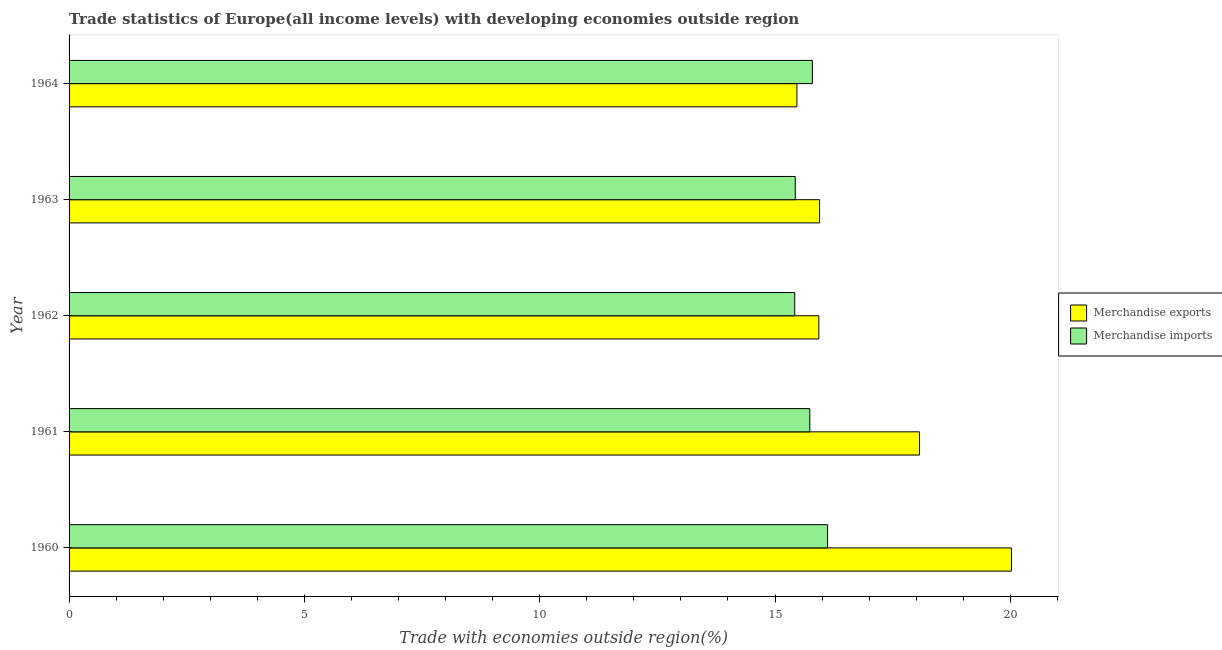How many different coloured bars are there?
Your response must be concise. 2. Are the number of bars on each tick of the Y-axis equal?
Keep it short and to the point. Yes. What is the label of the 4th group of bars from the top?
Offer a very short reply. 1961. In how many cases, is the number of bars for a given year not equal to the number of legend labels?
Give a very brief answer. 0. What is the merchandise exports in 1961?
Make the answer very short. 18.07. Across all years, what is the maximum merchandise exports?
Make the answer very short. 20.02. Across all years, what is the minimum merchandise exports?
Provide a short and direct response. 15.47. In which year was the merchandise imports maximum?
Your answer should be compact. 1960. What is the total merchandise imports in the graph?
Provide a succinct answer. 78.5. What is the difference between the merchandise exports in 1960 and that in 1963?
Provide a succinct answer. 4.08. What is the difference between the merchandise imports in 1962 and the merchandise exports in 1963?
Keep it short and to the point. -0.53. What is the average merchandise imports per year?
Your answer should be very brief. 15.7. In the year 1962, what is the difference between the merchandise exports and merchandise imports?
Your answer should be compact. 0.51. In how many years, is the merchandise exports greater than 20 %?
Make the answer very short. 1. What is the ratio of the merchandise exports in 1960 to that in 1964?
Keep it short and to the point. 1.29. Is the difference between the merchandise imports in 1962 and 1963 greater than the difference between the merchandise exports in 1962 and 1963?
Your response must be concise. Yes. What is the difference between the highest and the second highest merchandise exports?
Provide a short and direct response. 1.95. What is the difference between the highest and the lowest merchandise exports?
Your answer should be compact. 4.56. How many legend labels are there?
Provide a short and direct response. 2. What is the title of the graph?
Offer a very short reply. Trade statistics of Europe(all income levels) with developing economies outside region. What is the label or title of the X-axis?
Provide a succinct answer. Trade with economies outside region(%). What is the Trade with economies outside region(%) of Merchandise exports in 1960?
Give a very brief answer. 20.02. What is the Trade with economies outside region(%) of Merchandise imports in 1960?
Keep it short and to the point. 16.12. What is the Trade with economies outside region(%) of Merchandise exports in 1961?
Your response must be concise. 18.07. What is the Trade with economies outside region(%) in Merchandise imports in 1961?
Give a very brief answer. 15.74. What is the Trade with economies outside region(%) of Merchandise exports in 1962?
Keep it short and to the point. 15.93. What is the Trade with economies outside region(%) in Merchandise imports in 1962?
Ensure brevity in your answer.  15.42. What is the Trade with economies outside region(%) of Merchandise exports in 1963?
Your answer should be compact. 15.95. What is the Trade with economies outside region(%) of Merchandise imports in 1963?
Make the answer very short. 15.43. What is the Trade with economies outside region(%) in Merchandise exports in 1964?
Your answer should be very brief. 15.47. What is the Trade with economies outside region(%) in Merchandise imports in 1964?
Your response must be concise. 15.79. Across all years, what is the maximum Trade with economies outside region(%) in Merchandise exports?
Your answer should be compact. 20.02. Across all years, what is the maximum Trade with economies outside region(%) in Merchandise imports?
Give a very brief answer. 16.12. Across all years, what is the minimum Trade with economies outside region(%) of Merchandise exports?
Make the answer very short. 15.47. Across all years, what is the minimum Trade with economies outside region(%) of Merchandise imports?
Offer a terse response. 15.42. What is the total Trade with economies outside region(%) in Merchandise exports in the graph?
Offer a terse response. 85.44. What is the total Trade with economies outside region(%) of Merchandise imports in the graph?
Your answer should be very brief. 78.5. What is the difference between the Trade with economies outside region(%) in Merchandise exports in 1960 and that in 1961?
Your answer should be very brief. 1.95. What is the difference between the Trade with economies outside region(%) of Merchandise imports in 1960 and that in 1961?
Your answer should be very brief. 0.38. What is the difference between the Trade with economies outside region(%) of Merchandise exports in 1960 and that in 1962?
Offer a very short reply. 4.09. What is the difference between the Trade with economies outside region(%) of Merchandise imports in 1960 and that in 1962?
Provide a short and direct response. 0.7. What is the difference between the Trade with economies outside region(%) in Merchandise exports in 1960 and that in 1963?
Offer a very short reply. 4.08. What is the difference between the Trade with economies outside region(%) in Merchandise imports in 1960 and that in 1963?
Keep it short and to the point. 0.69. What is the difference between the Trade with economies outside region(%) in Merchandise exports in 1960 and that in 1964?
Your answer should be very brief. 4.56. What is the difference between the Trade with economies outside region(%) of Merchandise imports in 1960 and that in 1964?
Your answer should be compact. 0.32. What is the difference between the Trade with economies outside region(%) in Merchandise exports in 1961 and that in 1962?
Keep it short and to the point. 2.14. What is the difference between the Trade with economies outside region(%) in Merchandise imports in 1961 and that in 1962?
Offer a terse response. 0.32. What is the difference between the Trade with economies outside region(%) in Merchandise exports in 1961 and that in 1963?
Your answer should be very brief. 2.12. What is the difference between the Trade with economies outside region(%) of Merchandise imports in 1961 and that in 1963?
Your answer should be compact. 0.31. What is the difference between the Trade with economies outside region(%) in Merchandise exports in 1961 and that in 1964?
Give a very brief answer. 2.61. What is the difference between the Trade with economies outside region(%) of Merchandise imports in 1961 and that in 1964?
Offer a very short reply. -0.06. What is the difference between the Trade with economies outside region(%) in Merchandise exports in 1962 and that in 1963?
Provide a succinct answer. -0.02. What is the difference between the Trade with economies outside region(%) of Merchandise imports in 1962 and that in 1963?
Give a very brief answer. -0.01. What is the difference between the Trade with economies outside region(%) of Merchandise exports in 1962 and that in 1964?
Provide a short and direct response. 0.47. What is the difference between the Trade with economies outside region(%) in Merchandise imports in 1962 and that in 1964?
Keep it short and to the point. -0.38. What is the difference between the Trade with economies outside region(%) of Merchandise exports in 1963 and that in 1964?
Offer a very short reply. 0.48. What is the difference between the Trade with economies outside region(%) in Merchandise imports in 1963 and that in 1964?
Give a very brief answer. -0.36. What is the difference between the Trade with economies outside region(%) of Merchandise exports in 1960 and the Trade with economies outside region(%) of Merchandise imports in 1961?
Provide a succinct answer. 4.29. What is the difference between the Trade with economies outside region(%) of Merchandise exports in 1960 and the Trade with economies outside region(%) of Merchandise imports in 1962?
Your answer should be very brief. 4.61. What is the difference between the Trade with economies outside region(%) in Merchandise exports in 1960 and the Trade with economies outside region(%) in Merchandise imports in 1963?
Your answer should be very brief. 4.59. What is the difference between the Trade with economies outside region(%) of Merchandise exports in 1960 and the Trade with economies outside region(%) of Merchandise imports in 1964?
Provide a succinct answer. 4.23. What is the difference between the Trade with economies outside region(%) of Merchandise exports in 1961 and the Trade with economies outside region(%) of Merchandise imports in 1962?
Provide a succinct answer. 2.65. What is the difference between the Trade with economies outside region(%) in Merchandise exports in 1961 and the Trade with economies outside region(%) in Merchandise imports in 1963?
Make the answer very short. 2.64. What is the difference between the Trade with economies outside region(%) in Merchandise exports in 1961 and the Trade with economies outside region(%) in Merchandise imports in 1964?
Make the answer very short. 2.28. What is the difference between the Trade with economies outside region(%) in Merchandise exports in 1962 and the Trade with economies outside region(%) in Merchandise imports in 1963?
Offer a very short reply. 0.5. What is the difference between the Trade with economies outside region(%) of Merchandise exports in 1962 and the Trade with economies outside region(%) of Merchandise imports in 1964?
Make the answer very short. 0.14. What is the difference between the Trade with economies outside region(%) of Merchandise exports in 1963 and the Trade with economies outside region(%) of Merchandise imports in 1964?
Your answer should be very brief. 0.15. What is the average Trade with economies outside region(%) in Merchandise exports per year?
Give a very brief answer. 17.09. What is the average Trade with economies outside region(%) in Merchandise imports per year?
Offer a very short reply. 15.7. In the year 1960, what is the difference between the Trade with economies outside region(%) in Merchandise exports and Trade with economies outside region(%) in Merchandise imports?
Provide a short and direct response. 3.91. In the year 1961, what is the difference between the Trade with economies outside region(%) in Merchandise exports and Trade with economies outside region(%) in Merchandise imports?
Offer a terse response. 2.33. In the year 1962, what is the difference between the Trade with economies outside region(%) in Merchandise exports and Trade with economies outside region(%) in Merchandise imports?
Your answer should be compact. 0.51. In the year 1963, what is the difference between the Trade with economies outside region(%) of Merchandise exports and Trade with economies outside region(%) of Merchandise imports?
Give a very brief answer. 0.52. In the year 1964, what is the difference between the Trade with economies outside region(%) of Merchandise exports and Trade with economies outside region(%) of Merchandise imports?
Your response must be concise. -0.33. What is the ratio of the Trade with economies outside region(%) in Merchandise exports in 1960 to that in 1961?
Ensure brevity in your answer.  1.11. What is the ratio of the Trade with economies outside region(%) in Merchandise imports in 1960 to that in 1961?
Your answer should be compact. 1.02. What is the ratio of the Trade with economies outside region(%) of Merchandise exports in 1960 to that in 1962?
Provide a succinct answer. 1.26. What is the ratio of the Trade with economies outside region(%) in Merchandise imports in 1960 to that in 1962?
Offer a very short reply. 1.05. What is the ratio of the Trade with economies outside region(%) of Merchandise exports in 1960 to that in 1963?
Make the answer very short. 1.26. What is the ratio of the Trade with economies outside region(%) in Merchandise imports in 1960 to that in 1963?
Your answer should be compact. 1.04. What is the ratio of the Trade with economies outside region(%) of Merchandise exports in 1960 to that in 1964?
Ensure brevity in your answer.  1.29. What is the ratio of the Trade with economies outside region(%) of Merchandise imports in 1960 to that in 1964?
Give a very brief answer. 1.02. What is the ratio of the Trade with economies outside region(%) of Merchandise exports in 1961 to that in 1962?
Make the answer very short. 1.13. What is the ratio of the Trade with economies outside region(%) of Merchandise imports in 1961 to that in 1962?
Your answer should be compact. 1.02. What is the ratio of the Trade with economies outside region(%) in Merchandise exports in 1961 to that in 1963?
Ensure brevity in your answer.  1.13. What is the ratio of the Trade with economies outside region(%) of Merchandise imports in 1961 to that in 1963?
Make the answer very short. 1.02. What is the ratio of the Trade with economies outside region(%) in Merchandise exports in 1961 to that in 1964?
Provide a short and direct response. 1.17. What is the ratio of the Trade with economies outside region(%) in Merchandise imports in 1961 to that in 1964?
Your response must be concise. 1. What is the ratio of the Trade with economies outside region(%) of Merchandise exports in 1962 to that in 1963?
Ensure brevity in your answer.  1. What is the ratio of the Trade with economies outside region(%) in Merchandise imports in 1962 to that in 1963?
Provide a short and direct response. 1. What is the ratio of the Trade with economies outside region(%) of Merchandise exports in 1962 to that in 1964?
Provide a succinct answer. 1.03. What is the ratio of the Trade with economies outside region(%) in Merchandise imports in 1962 to that in 1964?
Your answer should be very brief. 0.98. What is the ratio of the Trade with economies outside region(%) of Merchandise exports in 1963 to that in 1964?
Your response must be concise. 1.03. What is the difference between the highest and the second highest Trade with economies outside region(%) in Merchandise exports?
Provide a short and direct response. 1.95. What is the difference between the highest and the second highest Trade with economies outside region(%) of Merchandise imports?
Ensure brevity in your answer.  0.32. What is the difference between the highest and the lowest Trade with economies outside region(%) of Merchandise exports?
Provide a short and direct response. 4.56. What is the difference between the highest and the lowest Trade with economies outside region(%) in Merchandise imports?
Your answer should be very brief. 0.7. 